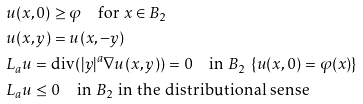<formula> <loc_0><loc_0><loc_500><loc_500>& u ( x , 0 ) \geq \varphi \quad \text {for $x\in B_{2}$} \\ & u ( x , y ) = u ( x , - y ) \\ & L _ { a } u = \text {div} ( | y | ^ { a } \nabla u ( x , y ) ) = 0 \quad \text {in $\mathcal{ }B_{2} \ \{u(x,0)=\varphi(x)\}$} \\ & L _ { a } u \leq 0 \quad \text {in $\mathcal{ }B_{2}$ in the distributional sense}</formula> 